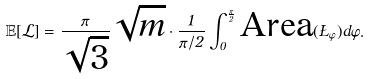Convert formula to latex. <formula><loc_0><loc_0><loc_500><loc_500>\mathbb { E } [ \mathcal { L } ] = \frac { \pi } { \sqrt { 3 } } \sqrt { m } \cdot \frac { 1 } { \pi / 2 } \int _ { 0 } ^ { \frac { \pi } { 2 } } \text {Area} ( \Sigma _ { \varphi } ) d \varphi .</formula> 